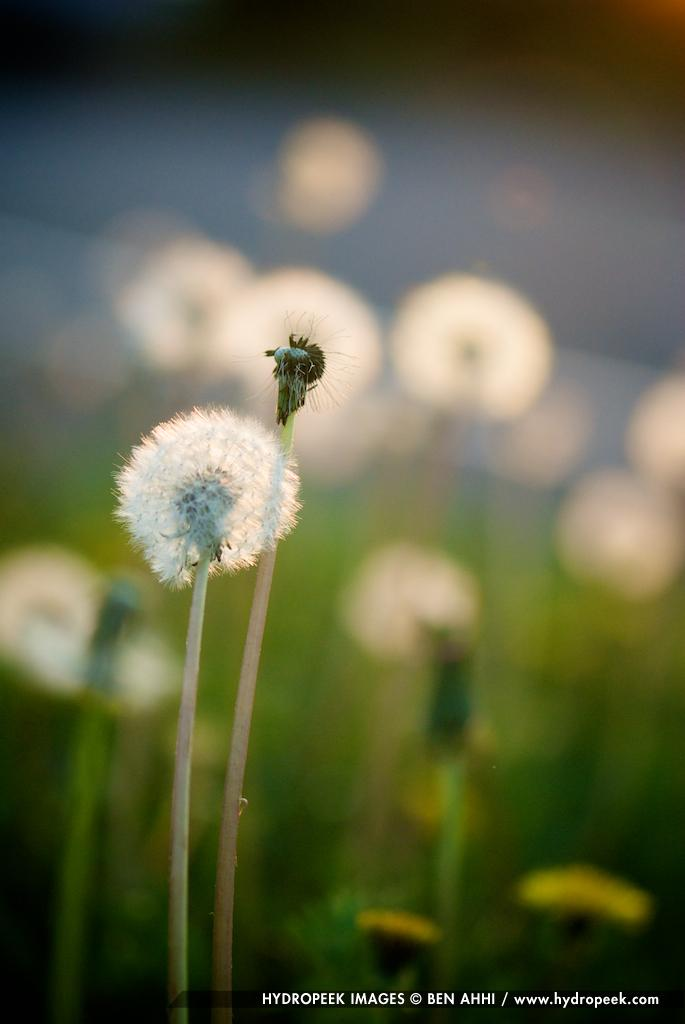What type of living organisms can be seen in the image? Flowers can be seen in the image. What type of bread can be seen in the image? There are: There is no bread present in the image; it only features flowers. 